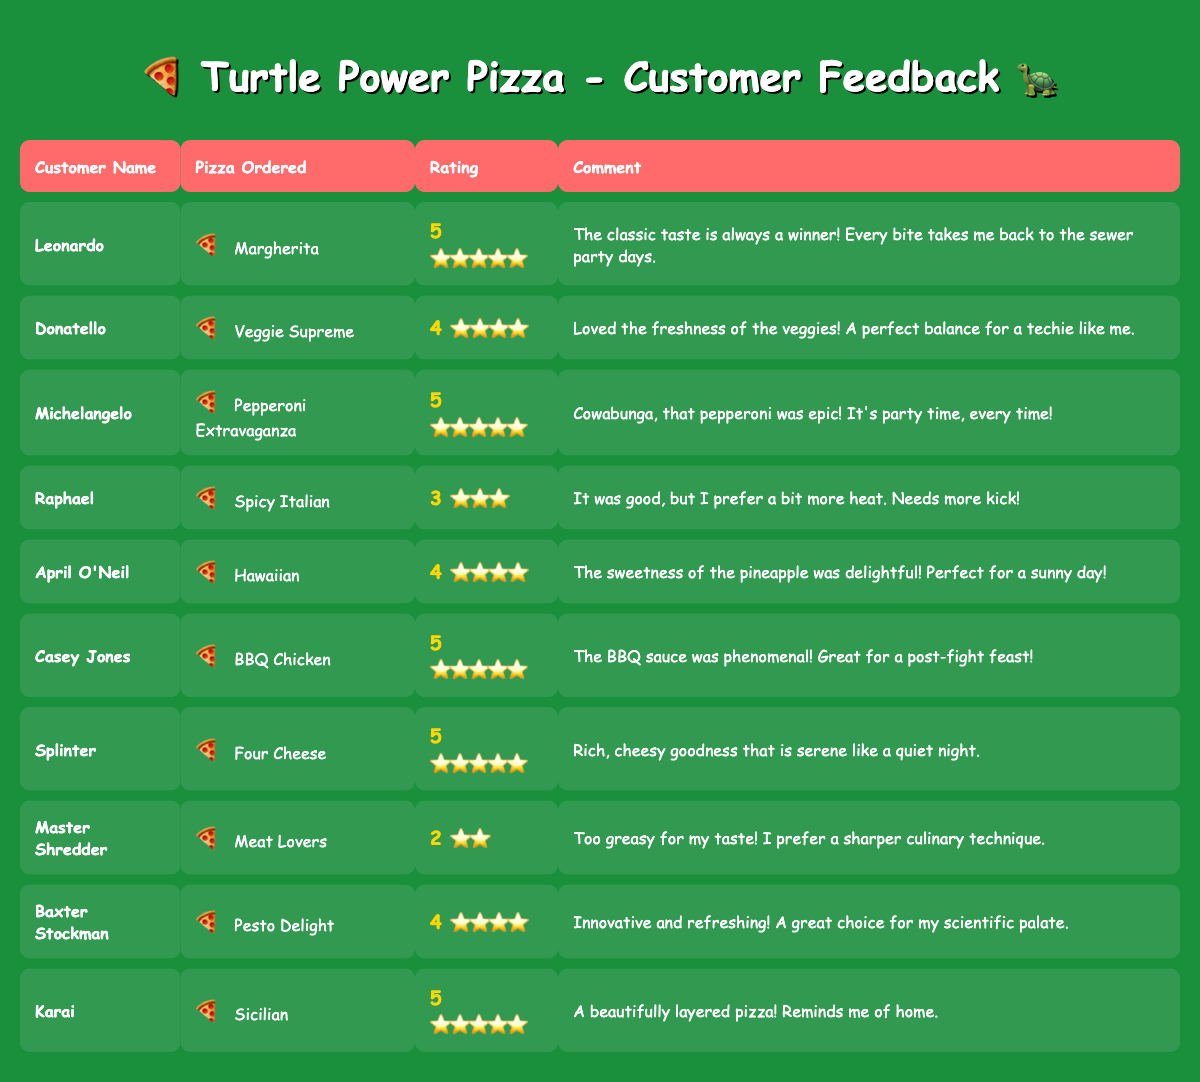What is the highest rating given to a pizza by a customer? From the table, multiple customers gave a rating of 5 to their pizzas: Leonardo, Michelangelo, Casey Jones, Splinter, and Karai. Therefore, the highest rating is 5.
Answer: 5 Which pizza has the lowest rating? The table shows that Master Shredder gave the lowest rating of 2 to the Meat Lovers pizza.
Answer: Meat Lovers How many customers rated their pizzas 4 or higher? Counting the ratings of 4 and 5: Leonardo (5), Donatello (4), Michelangelo (5), April O'Neil (4), Casey Jones (5), Splinter (5), Baxter Stockman (4), and Karai (5), that totals 8 customers.
Answer: 8 What is the average rating of all the pizzas ordered? The ratings are 5, 4, 5, 3, 4, 5, 5, 2, 4, and 5; adding these ratings gives 46, and dividing by 10 (the number of ratings) averages to 4.6.
Answer: 4.6 Are there more customers who ordered pizzas rated 5 than those who ordered pizzas rated below 5? The customers with ratings of 5 are Leonardo, Michelangelo, Casey Jones, Splinter, and Karai (5 customers), while Raphael (3), Master Shredder (2) are below 5; thus, there are more customers rating 5.
Answer: Yes What percentage of customers liked their pizzas enough to give them a rating of 4 or 5? 8 out of 10 customers rated their pizzas 4 or higher, which equals 80%.
Answer: 80% Which pizza received a rating of 3, and who ordered it? Raphael ordered the Spicy Italian pizza, and it received a rating of 3.
Answer: Spicy Italian, Raphael Is there a pizza that was rated 2 or lower? The only pizza rated 2 was the Meat Lovers ordered by Master Shredder; therefore, yes, there is one.
Answer: Yes Who provided the most positive feedback (rating of 5) on the creativity of the pizza? The customers who rated their pizzas as a 5 for creativity include Donatello with Veggie Supreme and Baxter Stockman with Pesto Delight, but Donatello's message emphasized freshness.
Answer: Donatello How many different types of pizzas received a rating of 5? The unique pizzas with a 5 rating are Margherita, Pepperoni Extravaganza, BBQ Chicken, Four Cheese, and Sicilian, which totals 5 types.
Answer: 5 